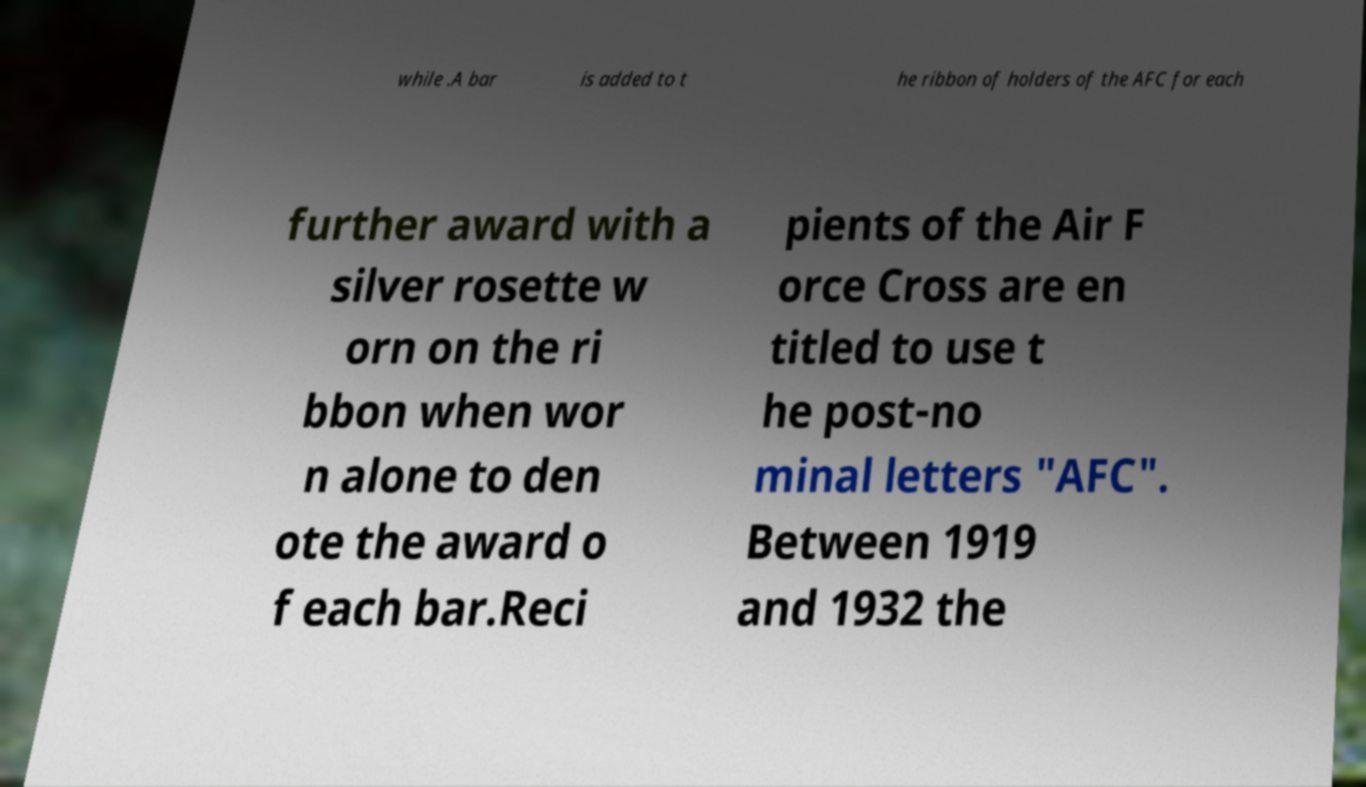There's text embedded in this image that I need extracted. Can you transcribe it verbatim? while .A bar is added to t he ribbon of holders of the AFC for each further award with a silver rosette w orn on the ri bbon when wor n alone to den ote the award o f each bar.Reci pients of the Air F orce Cross are en titled to use t he post-no minal letters "AFC". Between 1919 and 1932 the 